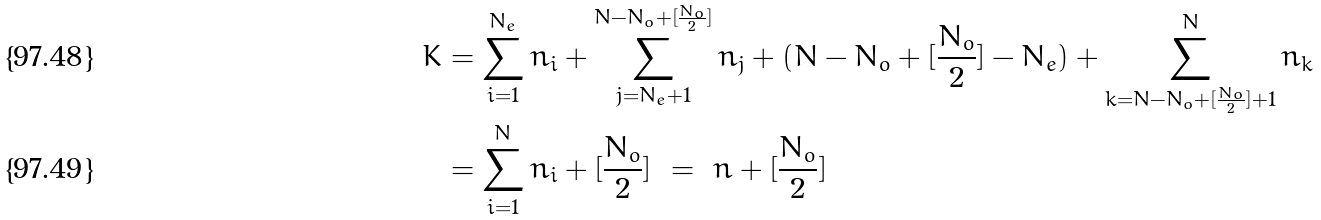Convert formula to latex. <formula><loc_0><loc_0><loc_500><loc_500>K & = { \sum _ { i = 1 } ^ { N _ { e } } n _ { i } + \sum _ { j = N _ { e } + 1 } ^ { N - N _ { o } + [ \frac { N _ { o } } { 2 } ] } n _ { j } + ( N - N _ { o } + [ \frac { N _ { o } } { 2 } ] - N _ { e } ) + \sum _ { k = N - N _ { o } + [ \frac { N _ { o } } { 2 } ] + 1 } ^ { N } n _ { k } } \\ & = \sum _ { i = 1 } ^ { N } n _ { i } + [ \frac { N _ { o } } { 2 } ] \ = \ n + [ \frac { N _ { o } } { 2 } ]</formula> 